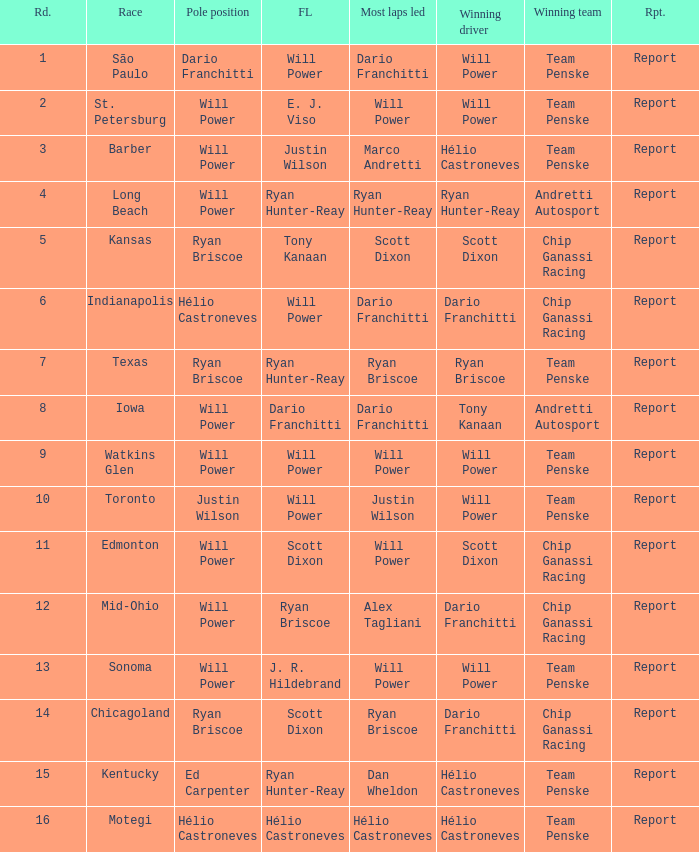What is the report for races where Will Power had both pole position and fastest lap? Report. Parse the table in full. {'header': ['Rd.', 'Race', 'Pole position', 'FL', 'Most laps led', 'Winning driver', 'Winning team', 'Rpt.'], 'rows': [['1', 'São Paulo', 'Dario Franchitti', 'Will Power', 'Dario Franchitti', 'Will Power', 'Team Penske', 'Report'], ['2', 'St. Petersburg', 'Will Power', 'E. J. Viso', 'Will Power', 'Will Power', 'Team Penske', 'Report'], ['3', 'Barber', 'Will Power', 'Justin Wilson', 'Marco Andretti', 'Hélio Castroneves', 'Team Penske', 'Report'], ['4', 'Long Beach', 'Will Power', 'Ryan Hunter-Reay', 'Ryan Hunter-Reay', 'Ryan Hunter-Reay', 'Andretti Autosport', 'Report'], ['5', 'Kansas', 'Ryan Briscoe', 'Tony Kanaan', 'Scott Dixon', 'Scott Dixon', 'Chip Ganassi Racing', 'Report'], ['6', 'Indianapolis', 'Hélio Castroneves', 'Will Power', 'Dario Franchitti', 'Dario Franchitti', 'Chip Ganassi Racing', 'Report'], ['7', 'Texas', 'Ryan Briscoe', 'Ryan Hunter-Reay', 'Ryan Briscoe', 'Ryan Briscoe', 'Team Penske', 'Report'], ['8', 'Iowa', 'Will Power', 'Dario Franchitti', 'Dario Franchitti', 'Tony Kanaan', 'Andretti Autosport', 'Report'], ['9', 'Watkins Glen', 'Will Power', 'Will Power', 'Will Power', 'Will Power', 'Team Penske', 'Report'], ['10', 'Toronto', 'Justin Wilson', 'Will Power', 'Justin Wilson', 'Will Power', 'Team Penske', 'Report'], ['11', 'Edmonton', 'Will Power', 'Scott Dixon', 'Will Power', 'Scott Dixon', 'Chip Ganassi Racing', 'Report'], ['12', 'Mid-Ohio', 'Will Power', 'Ryan Briscoe', 'Alex Tagliani', 'Dario Franchitti', 'Chip Ganassi Racing', 'Report'], ['13', 'Sonoma', 'Will Power', 'J. R. Hildebrand', 'Will Power', 'Will Power', 'Team Penske', 'Report'], ['14', 'Chicagoland', 'Ryan Briscoe', 'Scott Dixon', 'Ryan Briscoe', 'Dario Franchitti', 'Chip Ganassi Racing', 'Report'], ['15', 'Kentucky', 'Ed Carpenter', 'Ryan Hunter-Reay', 'Dan Wheldon', 'Hélio Castroneves', 'Team Penske', 'Report'], ['16', 'Motegi', 'Hélio Castroneves', 'Hélio Castroneves', 'Hélio Castroneves', 'Hélio Castroneves', 'Team Penske', 'Report']]} 